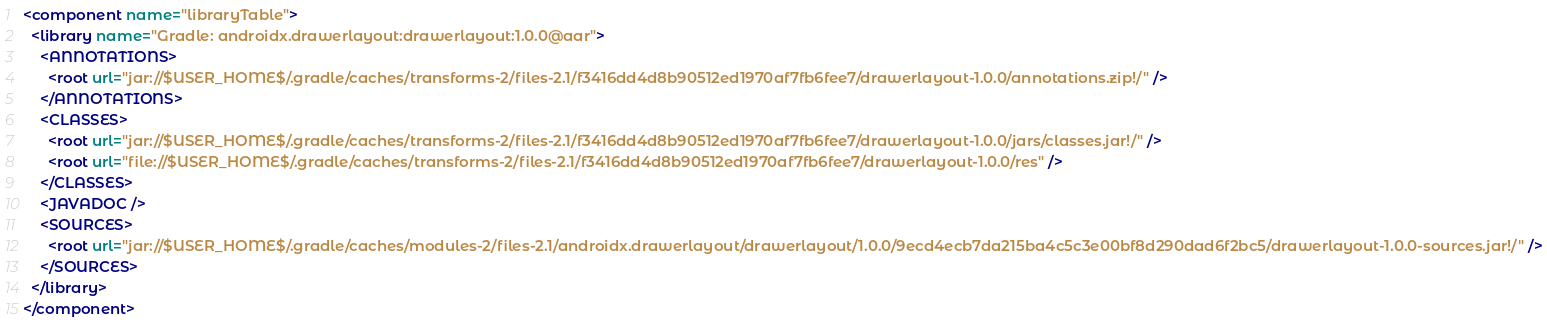Convert code to text. <code><loc_0><loc_0><loc_500><loc_500><_XML_><component name="libraryTable">
  <library name="Gradle: androidx.drawerlayout:drawerlayout:1.0.0@aar">
    <ANNOTATIONS>
      <root url="jar://$USER_HOME$/.gradle/caches/transforms-2/files-2.1/f3416dd4d8b90512ed1970af7fb6fee7/drawerlayout-1.0.0/annotations.zip!/" />
    </ANNOTATIONS>
    <CLASSES>
      <root url="jar://$USER_HOME$/.gradle/caches/transforms-2/files-2.1/f3416dd4d8b90512ed1970af7fb6fee7/drawerlayout-1.0.0/jars/classes.jar!/" />
      <root url="file://$USER_HOME$/.gradle/caches/transforms-2/files-2.1/f3416dd4d8b90512ed1970af7fb6fee7/drawerlayout-1.0.0/res" />
    </CLASSES>
    <JAVADOC />
    <SOURCES>
      <root url="jar://$USER_HOME$/.gradle/caches/modules-2/files-2.1/androidx.drawerlayout/drawerlayout/1.0.0/9ecd4ecb7da215ba4c5c3e00bf8d290dad6f2bc5/drawerlayout-1.0.0-sources.jar!/" />
    </SOURCES>
  </library>
</component></code> 